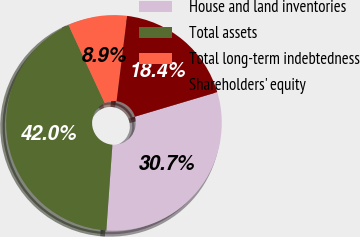<chart> <loc_0><loc_0><loc_500><loc_500><pie_chart><fcel>House and land inventories<fcel>Total assets<fcel>Total long-term indebtedness<fcel>Shareholders' equity<nl><fcel>30.73%<fcel>41.95%<fcel>8.87%<fcel>18.44%<nl></chart> 